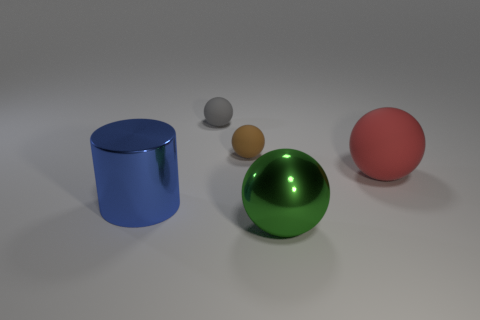What is the material of the green object that is the same size as the cylinder?
Give a very brief answer. Metal. Are there any other big metal spheres of the same color as the big metallic sphere?
Give a very brief answer. No. What shape is the large object that is both on the left side of the large matte object and right of the blue object?
Your response must be concise. Sphere. What number of large blue cubes are made of the same material as the big cylinder?
Ensure brevity in your answer.  0. Is the number of red matte objects behind the brown rubber object less than the number of small gray rubber balls on the right side of the big green ball?
Offer a terse response. No. There is a thing that is right of the large thing in front of the metal thing left of the gray sphere; what is its material?
Make the answer very short. Rubber. What size is the rubber sphere that is to the left of the green ball and in front of the gray object?
Make the answer very short. Small. How many cubes are rubber objects or brown matte things?
Keep it short and to the point. 0. There is a rubber thing that is the same size as the blue cylinder; what is its color?
Your answer should be very brief. Red. Are there any other things that have the same shape as the large red matte object?
Give a very brief answer. Yes. 